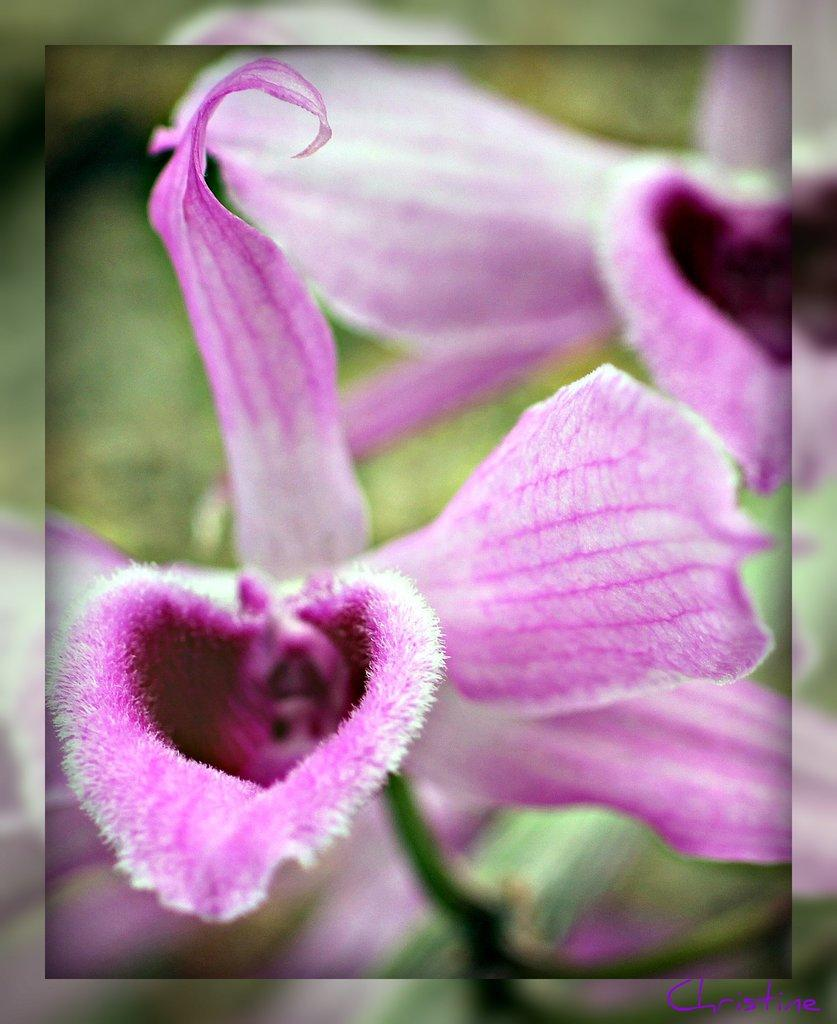What type of flowers can be seen on the plant in the image? There are pink flowers on a plant in the image. How would you describe the background of the image? The background of the image appears blurry. What type of vegetation is visible in the image? Grass is present in the image. What type of meat is being sold at the business in the image? There is no business or meat present in the image; it features pink flowers on a plant and a blurry background. 